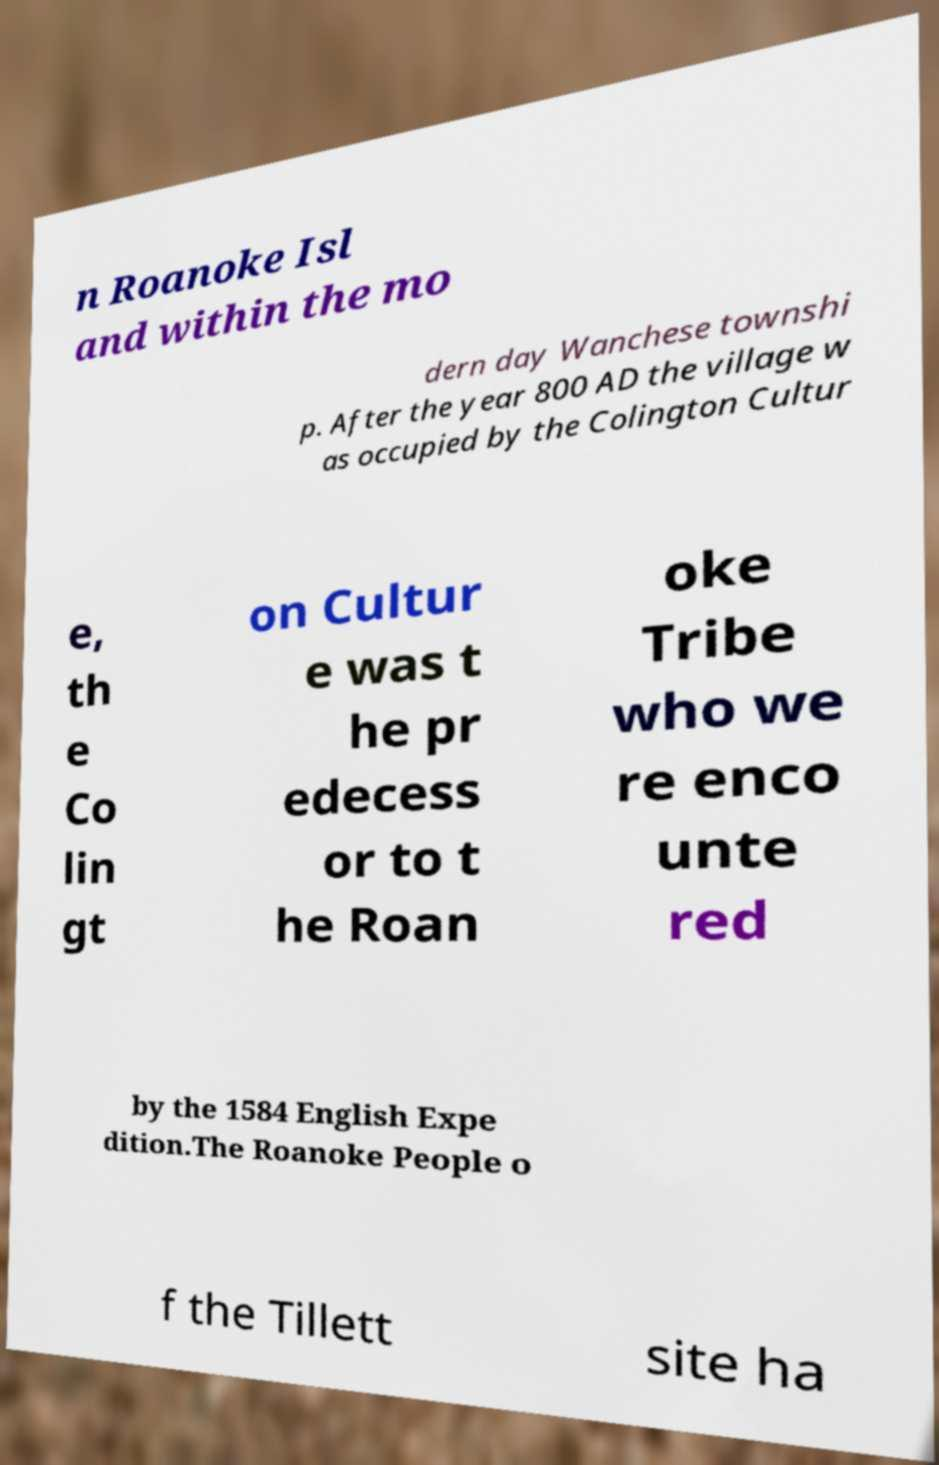Can you read and provide the text displayed in the image?This photo seems to have some interesting text. Can you extract and type it out for me? n Roanoke Isl and within the mo dern day Wanchese townshi p. After the year 800 AD the village w as occupied by the Colington Cultur e, th e Co lin gt on Cultur e was t he pr edecess or to t he Roan oke Tribe who we re enco unte red by the 1584 English Expe dition.The Roanoke People o f the Tillett site ha 